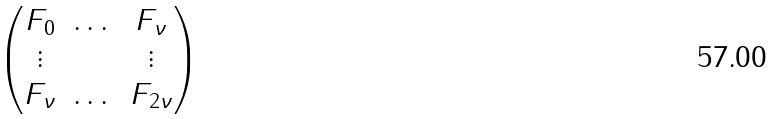Convert formula to latex. <formula><loc_0><loc_0><loc_500><loc_500>\begin{pmatrix} F _ { 0 } & \dots & F _ { \nu } \\ \vdots & & \vdots \\ F _ { \nu } & \dots & F _ { 2 \nu } \end{pmatrix}</formula> 